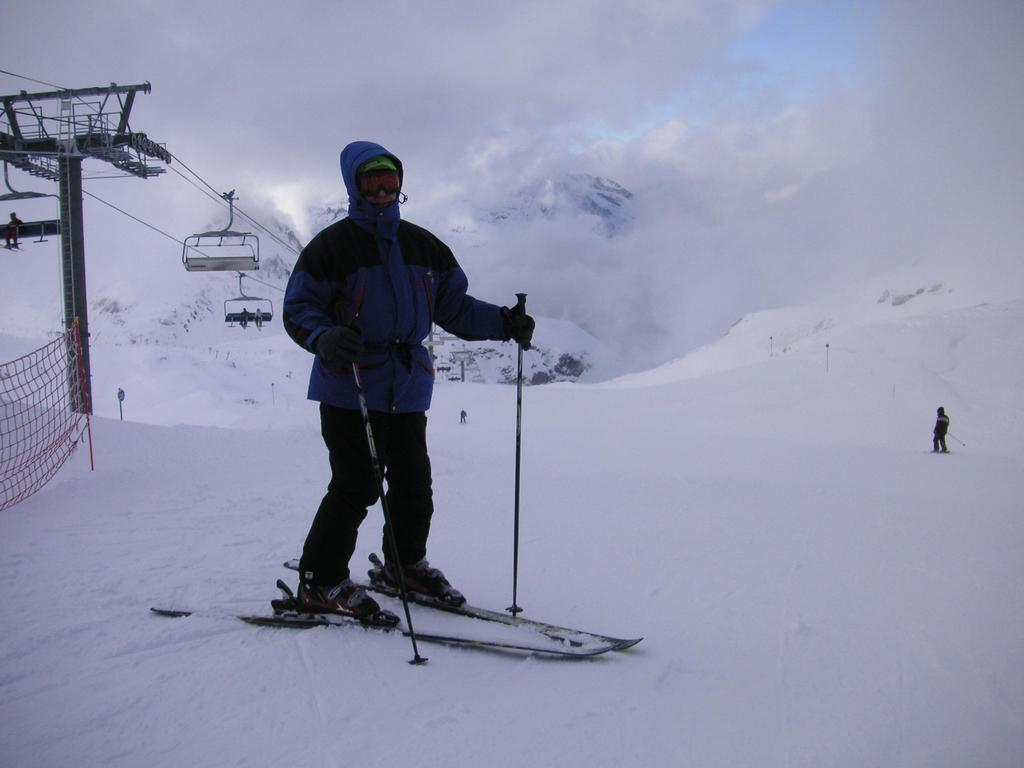What are the people doing on the snow in the image? The people are standing on ski boards in the image. What can be seen in the background of the image? There is sky, mountains, a net, and persons sitting in a ropeway visible in the background. How many people are in the ropeway in the background? There are persons sitting in a ropeway in the background, but the exact number cannot be determined from the image. Can you see a circle being blown by someone in the image? There is no circle being blown by someone in the image. Are the people in the image kissing each other? There is no indication of people kissing in the image; they are standing on ski boards on the snow. 